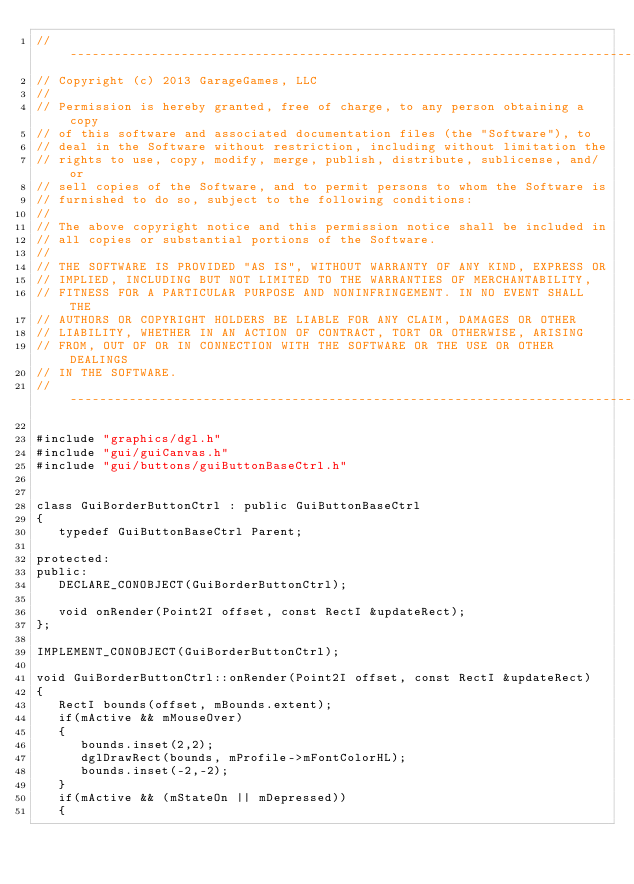<code> <loc_0><loc_0><loc_500><loc_500><_C++_>//-----------------------------------------------------------------------------
// Copyright (c) 2013 GarageGames, LLC
//
// Permission is hereby granted, free of charge, to any person obtaining a copy
// of this software and associated documentation files (the "Software"), to
// deal in the Software without restriction, including without limitation the
// rights to use, copy, modify, merge, publish, distribute, sublicense, and/or
// sell copies of the Software, and to permit persons to whom the Software is
// furnished to do so, subject to the following conditions:
//
// The above copyright notice and this permission notice shall be included in
// all copies or substantial portions of the Software.
//
// THE SOFTWARE IS PROVIDED "AS IS", WITHOUT WARRANTY OF ANY KIND, EXPRESS OR
// IMPLIED, INCLUDING BUT NOT LIMITED TO THE WARRANTIES OF MERCHANTABILITY,
// FITNESS FOR A PARTICULAR PURPOSE AND NONINFRINGEMENT. IN NO EVENT SHALL THE
// AUTHORS OR COPYRIGHT HOLDERS BE LIABLE FOR ANY CLAIM, DAMAGES OR OTHER
// LIABILITY, WHETHER IN AN ACTION OF CONTRACT, TORT OR OTHERWISE, ARISING
// FROM, OUT OF OR IN CONNECTION WITH THE SOFTWARE OR THE USE OR OTHER DEALINGS
// IN THE SOFTWARE.
//-----------------------------------------------------------------------------

#include "graphics/dgl.h"
#include "gui/guiCanvas.h"
#include "gui/buttons/guiButtonBaseCtrl.h"


class GuiBorderButtonCtrl : public GuiButtonBaseCtrl
{
   typedef GuiButtonBaseCtrl Parent;

protected:
public:
   DECLARE_CONOBJECT(GuiBorderButtonCtrl);

   void onRender(Point2I offset, const RectI &updateRect);
};

IMPLEMENT_CONOBJECT(GuiBorderButtonCtrl);

void GuiBorderButtonCtrl::onRender(Point2I offset, const RectI &updateRect)
{
   RectI bounds(offset, mBounds.extent);
   if(mActive && mMouseOver)
   {
      bounds.inset(2,2);
      dglDrawRect(bounds, mProfile->mFontColorHL);
      bounds.inset(-2,-2);
   }
   if(mActive && (mStateOn || mDepressed))
   {</code> 